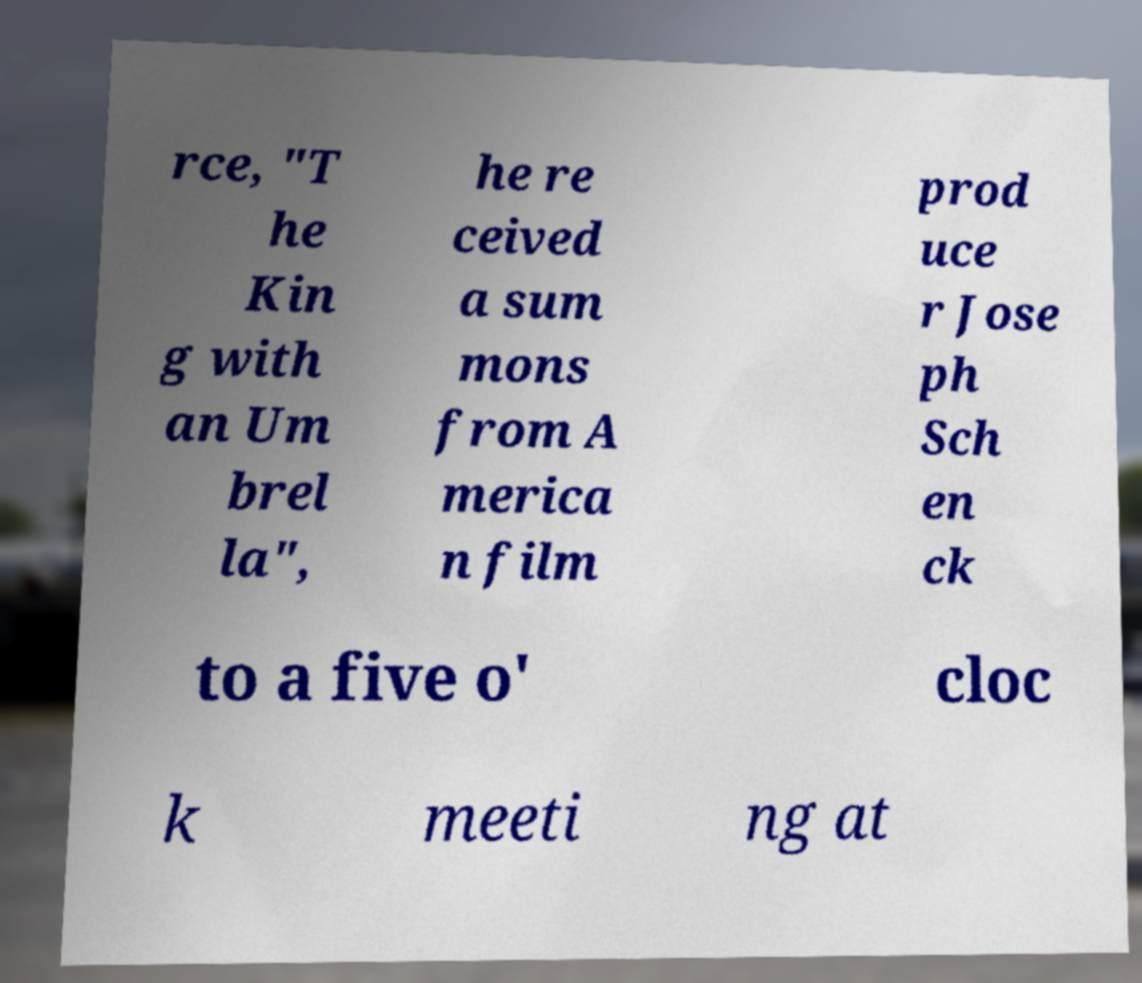I need the written content from this picture converted into text. Can you do that? rce, "T he Kin g with an Um brel la", he re ceived a sum mons from A merica n film prod uce r Jose ph Sch en ck to a five o' cloc k meeti ng at 